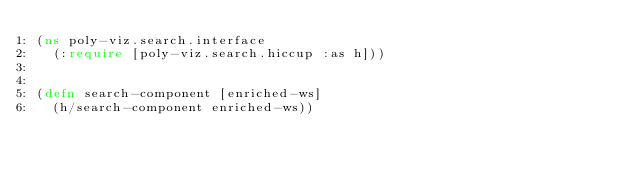Convert code to text. <code><loc_0><loc_0><loc_500><loc_500><_Clojure_>(ns poly-viz.search.interface
  (:require [poly-viz.search.hiccup :as h]))


(defn search-component [enriched-ws]
  (h/search-component enriched-ws))
</code> 